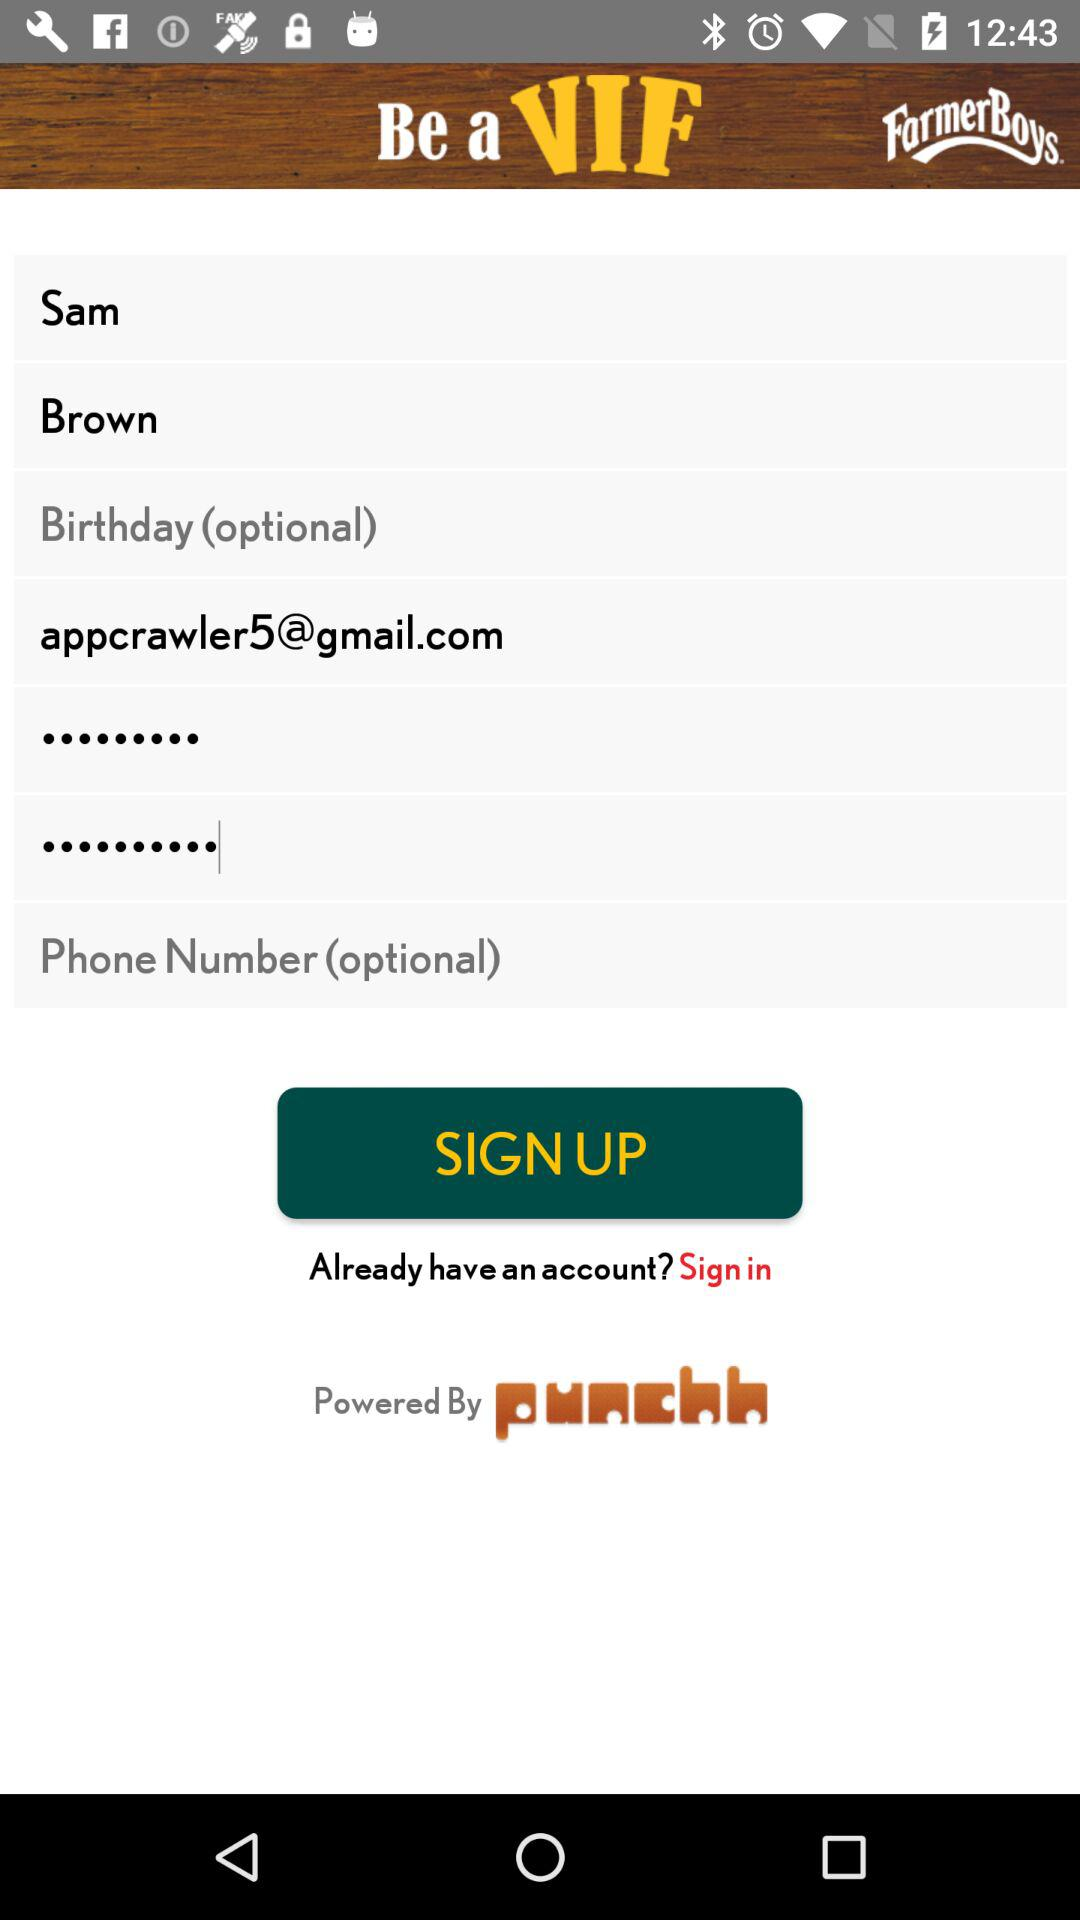What is the surname of the user? The surname is Brown. 